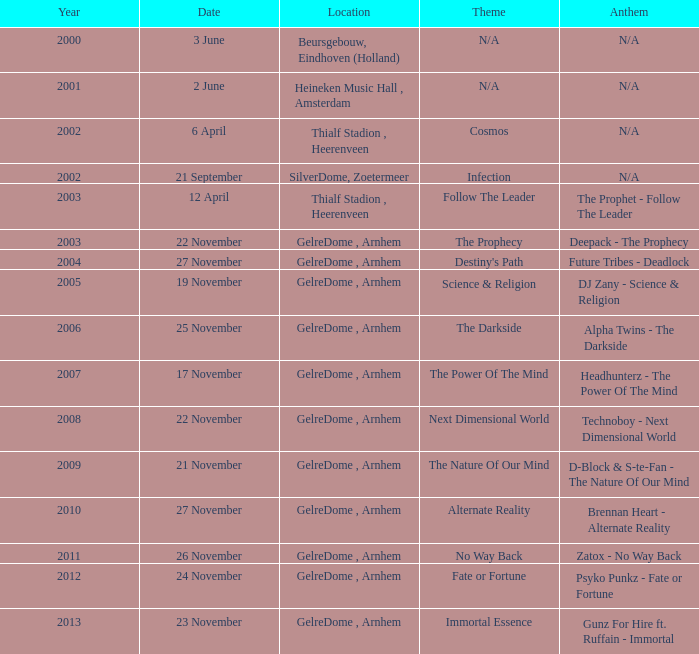What date has a theme of predestination or chance? 24 November. 